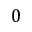<formula> <loc_0><loc_0><loc_500><loc_500>0</formula> 